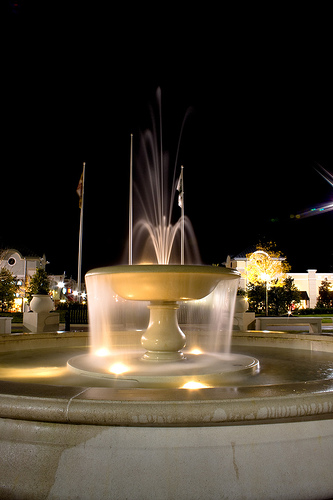<image>
Is there a fountain behind the flag? No. The fountain is not behind the flag. From this viewpoint, the fountain appears to be positioned elsewhere in the scene. 